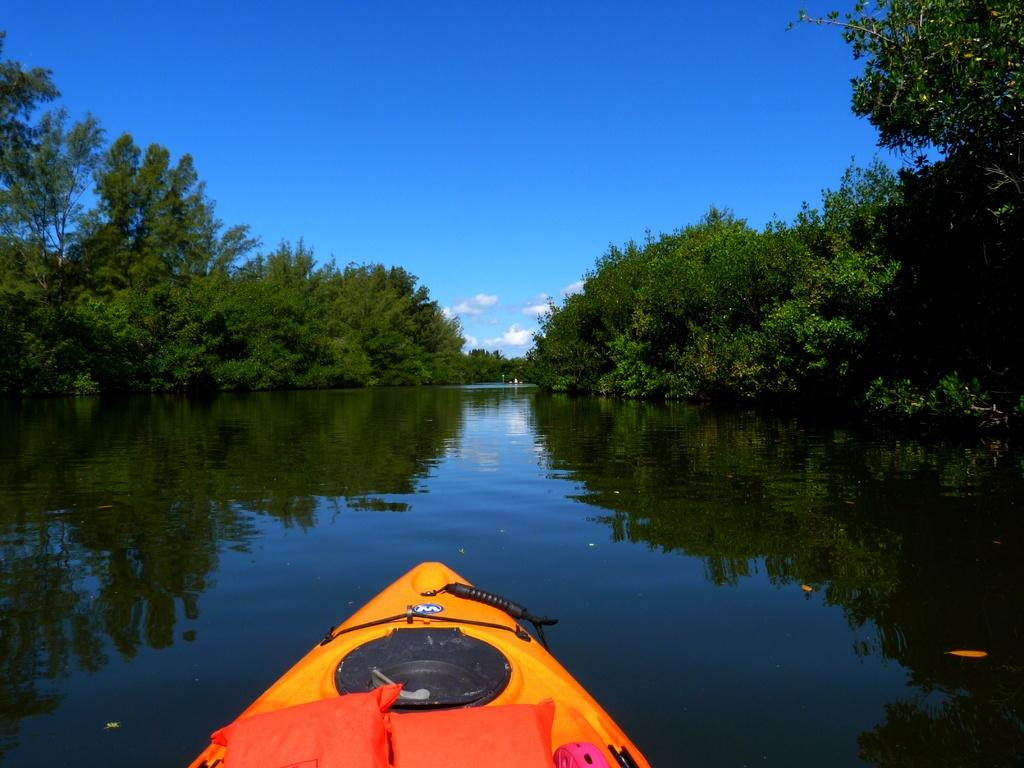What type of objects can be seen in the image? There are pillows and objects on a boat in the image. Where is the boat located in the image? The boat is on water in the image. What can be seen in the background of the image? There are trees and the sky visible in the background of the image. What is the condition of the sky in the image? Clouds are present in the sky in the image. Where is the nearest market to the boat in the image? There is no information about a market in the image, so it cannot be determined. What time is indicated by the clock on the boat in the image? There is no clock present in the image. 